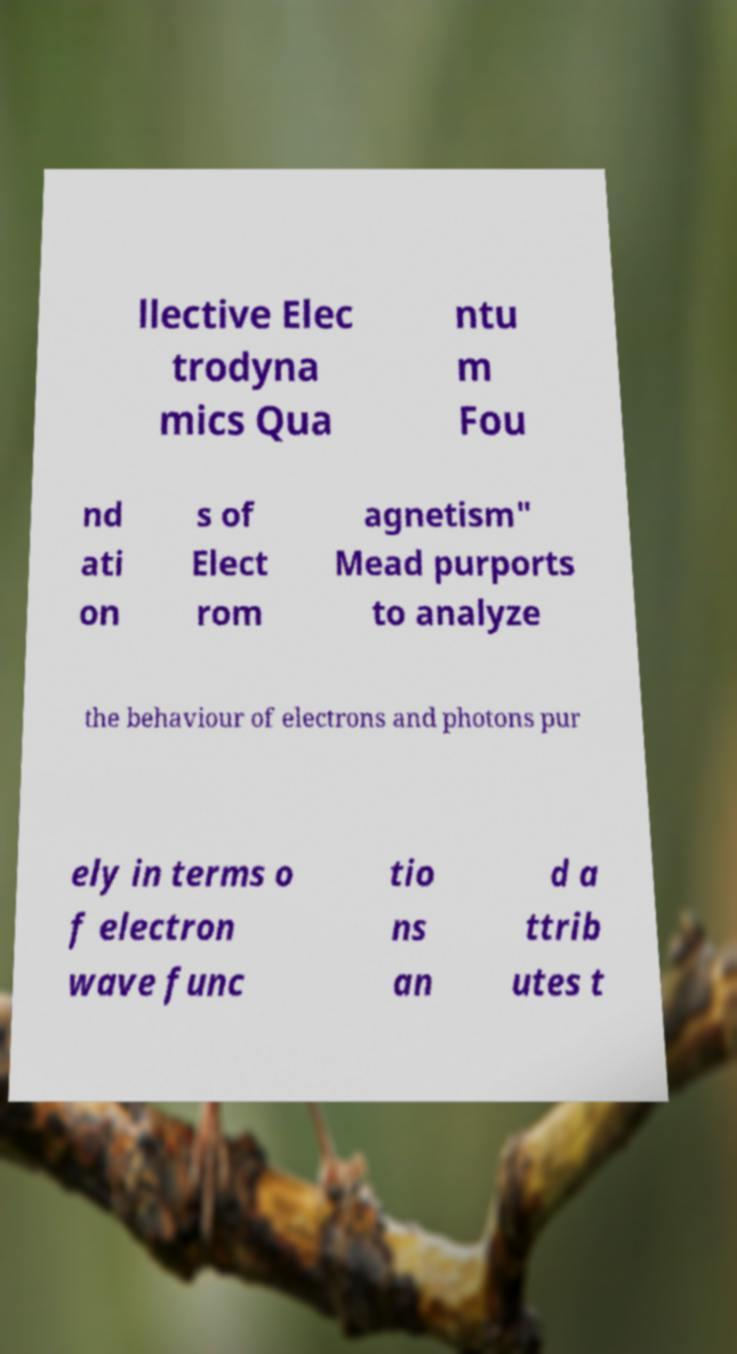Please identify and transcribe the text found in this image. llective Elec trodyna mics Qua ntu m Fou nd ati on s of Elect rom agnetism" Mead purports to analyze the behaviour of electrons and photons pur ely in terms o f electron wave func tio ns an d a ttrib utes t 